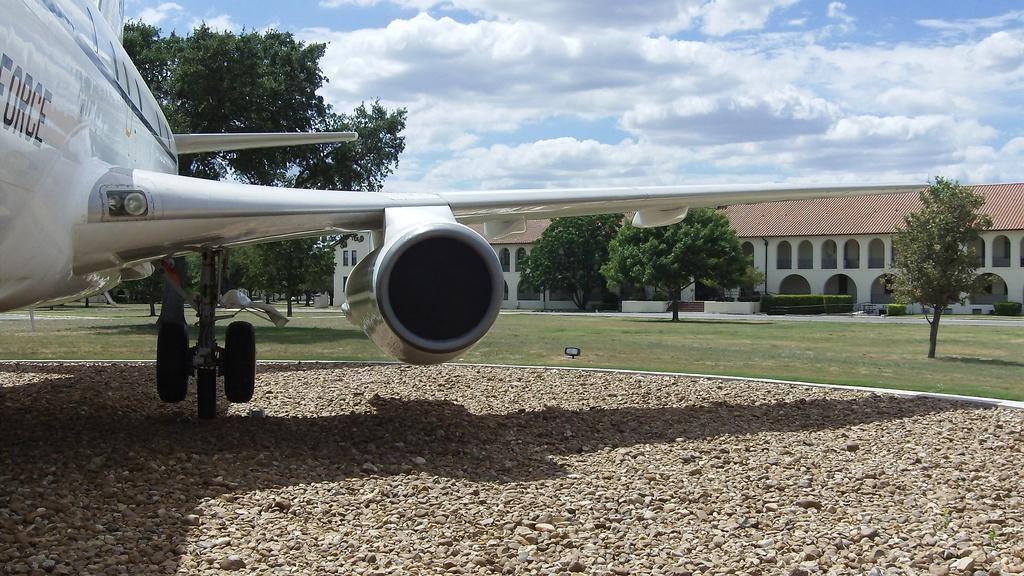<image>
Describe the image concisely. Air Force Plane that is parked on the muddle of a yard. 